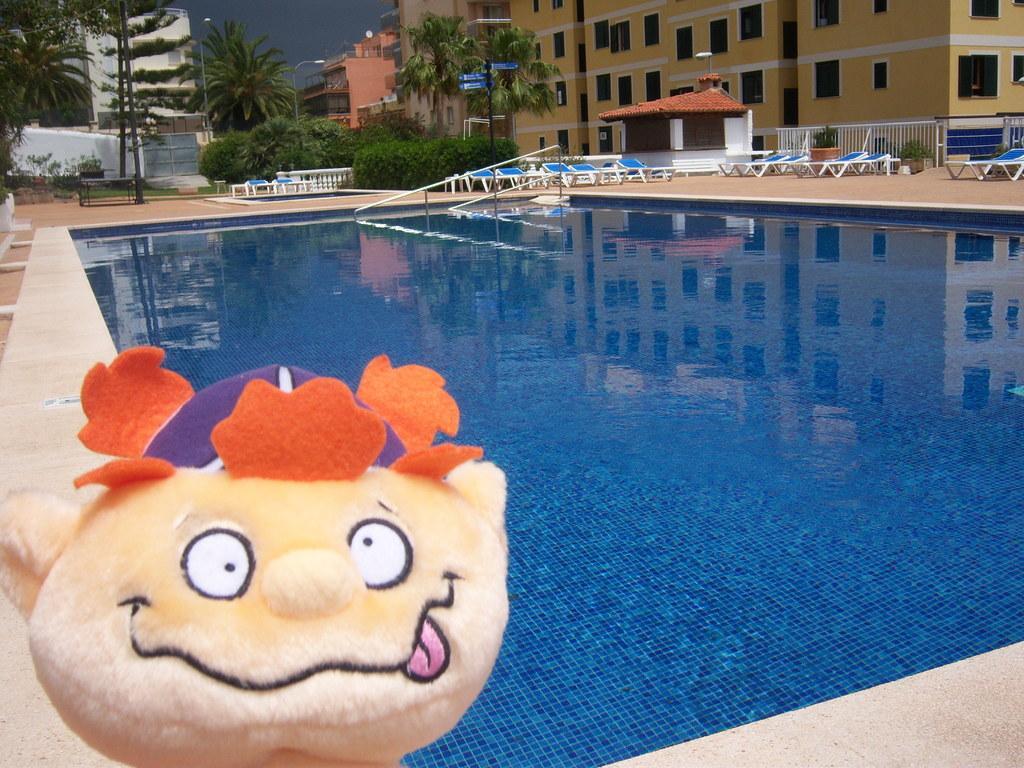Describe this image in one or two sentences. In this picture I can see there is a doll and there is a swimming pool here. It has water in it. There are few chairs, plants, trees and buildings in the backdrop. 